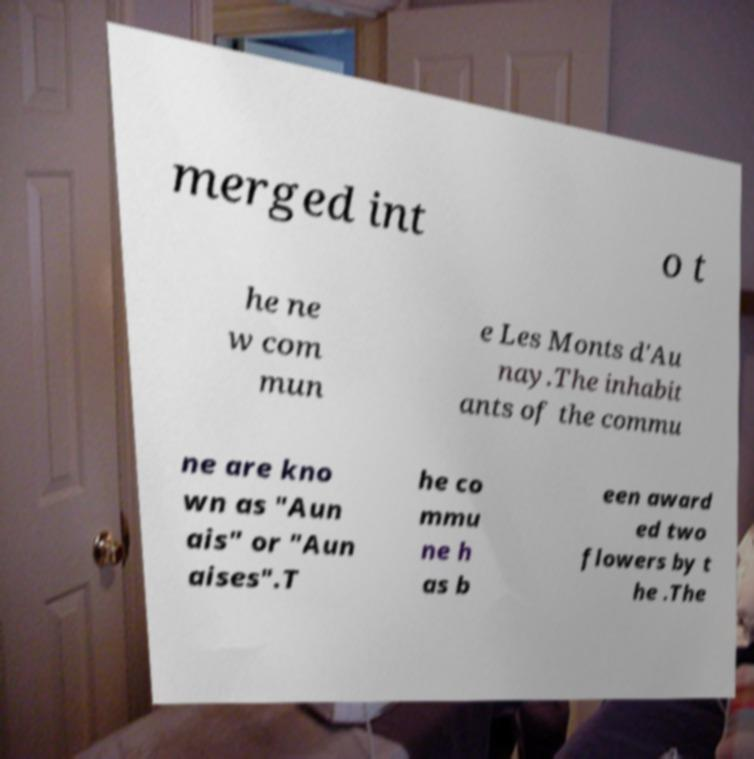Could you extract and type out the text from this image? merged int o t he ne w com mun e Les Monts d'Au nay.The inhabit ants of the commu ne are kno wn as "Aun ais" or "Aun aises".T he co mmu ne h as b een award ed two flowers by t he .The 